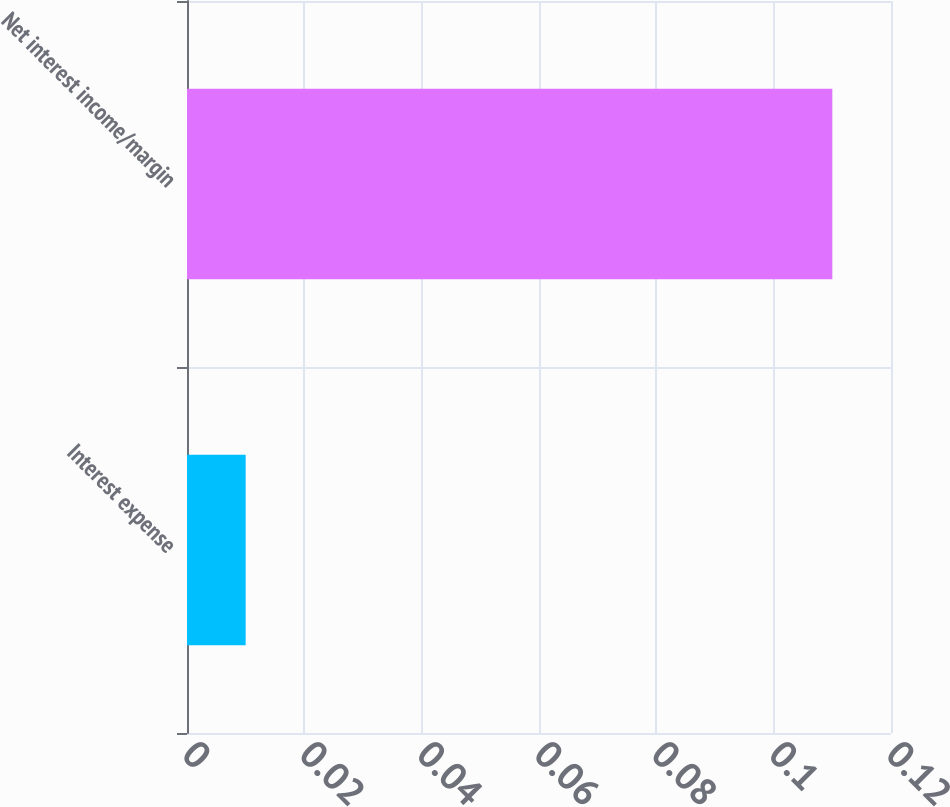<chart> <loc_0><loc_0><loc_500><loc_500><bar_chart><fcel>Interest expense<fcel>Net interest income/margin<nl><fcel>0.01<fcel>0.11<nl></chart> 